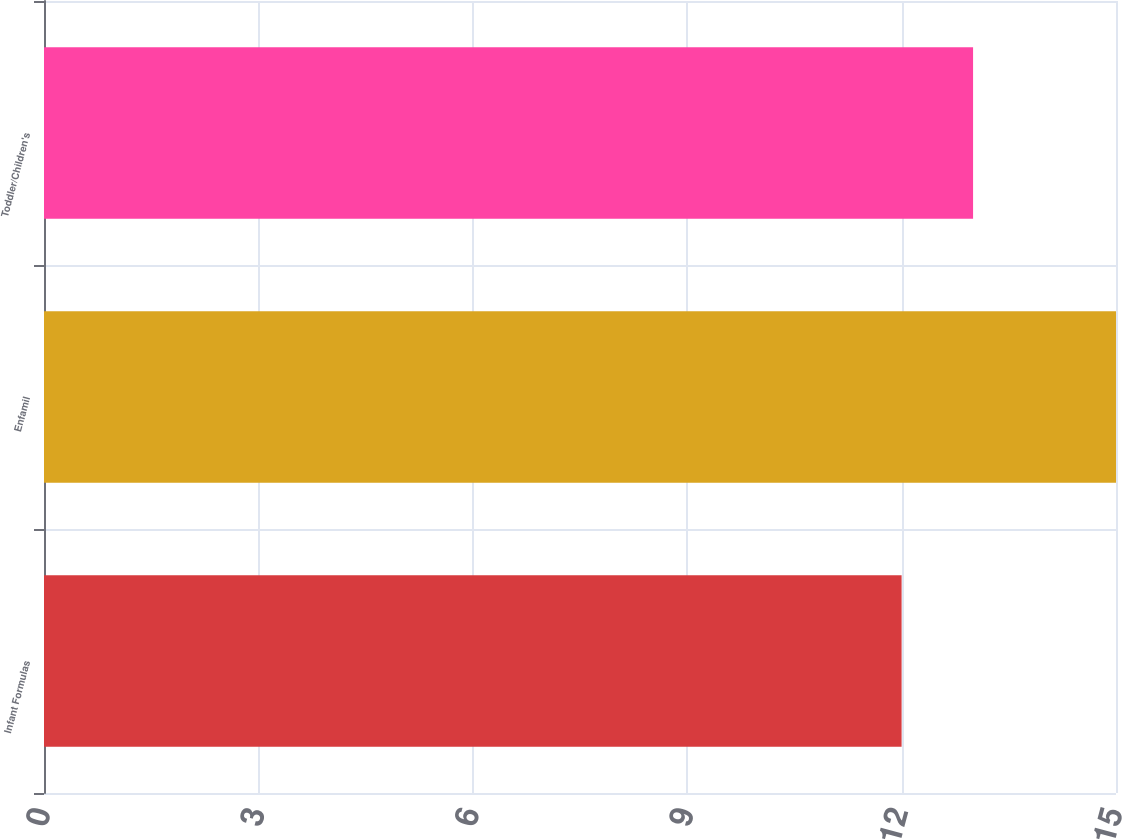Convert chart to OTSL. <chart><loc_0><loc_0><loc_500><loc_500><bar_chart><fcel>Infant Formulas<fcel>Enfamil<fcel>Toddler/Children's<nl><fcel>12<fcel>15<fcel>13<nl></chart> 